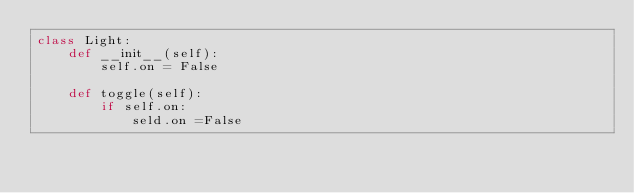<code> <loc_0><loc_0><loc_500><loc_500><_Python_>class Light:
    def __init__(self):
        self.on = False

    def toggle(self):
        if self.on:
            seld.on =False

</code> 